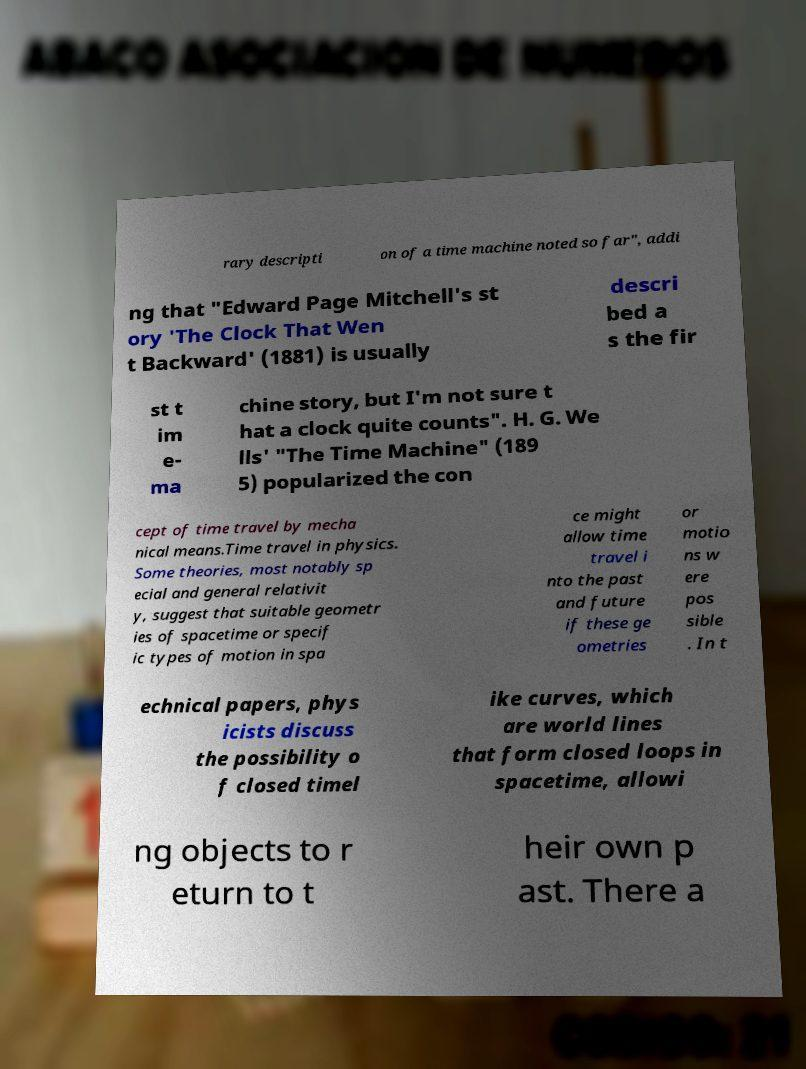Can you read and provide the text displayed in the image?This photo seems to have some interesting text. Can you extract and type it out for me? rary descripti on of a time machine noted so far", addi ng that "Edward Page Mitchell's st ory 'The Clock That Wen t Backward' (1881) is usually descri bed a s the fir st t im e- ma chine story, but I'm not sure t hat a clock quite counts". H. G. We lls' "The Time Machine" (189 5) popularized the con cept of time travel by mecha nical means.Time travel in physics. Some theories, most notably sp ecial and general relativit y, suggest that suitable geometr ies of spacetime or specif ic types of motion in spa ce might allow time travel i nto the past and future if these ge ometries or motio ns w ere pos sible . In t echnical papers, phys icists discuss the possibility o f closed timel ike curves, which are world lines that form closed loops in spacetime, allowi ng objects to r eturn to t heir own p ast. There a 